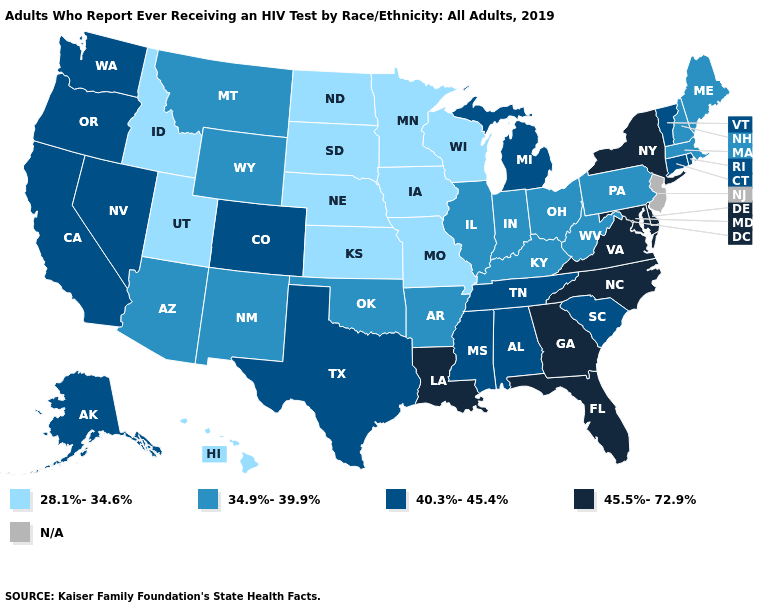Name the states that have a value in the range 28.1%-34.6%?
Give a very brief answer. Hawaii, Idaho, Iowa, Kansas, Minnesota, Missouri, Nebraska, North Dakota, South Dakota, Utah, Wisconsin. What is the value of Virginia?
Quick response, please. 45.5%-72.9%. Name the states that have a value in the range 45.5%-72.9%?
Be succinct. Delaware, Florida, Georgia, Louisiana, Maryland, New York, North Carolina, Virginia. What is the value of Rhode Island?
Quick response, please. 40.3%-45.4%. Among the states that border Oregon , does Nevada have the highest value?
Answer briefly. Yes. Which states have the highest value in the USA?
Answer briefly. Delaware, Florida, Georgia, Louisiana, Maryland, New York, North Carolina, Virginia. Name the states that have a value in the range N/A?
Give a very brief answer. New Jersey. Does the map have missing data?
Short answer required. Yes. Name the states that have a value in the range 40.3%-45.4%?
Give a very brief answer. Alabama, Alaska, California, Colorado, Connecticut, Michigan, Mississippi, Nevada, Oregon, Rhode Island, South Carolina, Tennessee, Texas, Vermont, Washington. What is the value of Montana?
Give a very brief answer. 34.9%-39.9%. What is the value of West Virginia?
Be succinct. 34.9%-39.9%. Among the states that border Kentucky , which have the lowest value?
Concise answer only. Missouri. What is the highest value in the South ?
Be succinct. 45.5%-72.9%. 